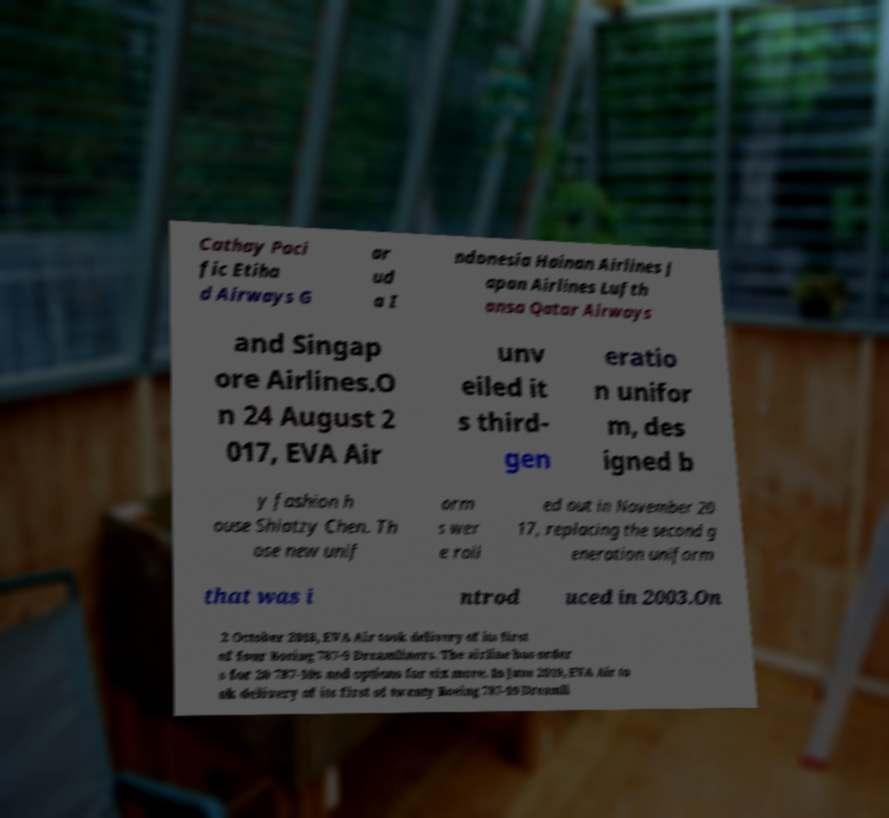What messages or text are displayed in this image? I need them in a readable, typed format. Cathay Paci fic Etiha d Airways G ar ud a I ndonesia Hainan Airlines J apan Airlines Lufth ansa Qatar Airways and Singap ore Airlines.O n 24 August 2 017, EVA Air unv eiled it s third- gen eratio n unifor m, des igned b y fashion h ouse Shiatzy Chen. Th ose new unif orm s wer e roll ed out in November 20 17, replacing the second g eneration uniform that was i ntrod uced in 2003.On 2 October 2018, EVA Air took delivery of its first of four Boeing 787-9 Dreamliners. The airline has order s for 20 787-10s and options for six more. In June 2019, EVA Air to ok delivery of its first of twenty Boeing 787-10 Dreamli 